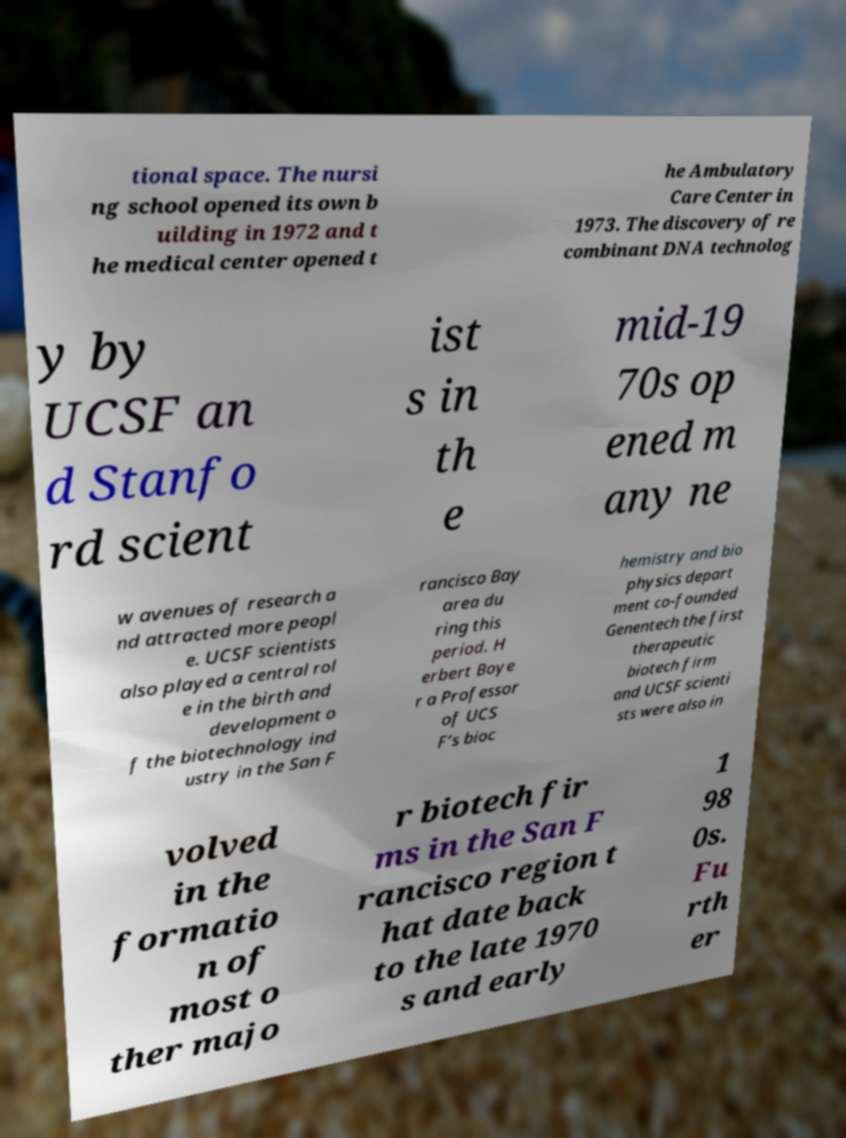Can you accurately transcribe the text from the provided image for me? tional space. The nursi ng school opened its own b uilding in 1972 and t he medical center opened t he Ambulatory Care Center in 1973. The discovery of re combinant DNA technolog y by UCSF an d Stanfo rd scient ist s in th e mid-19 70s op ened m any ne w avenues of research a nd attracted more peopl e. UCSF scientists also played a central rol e in the birth and development o f the biotechnology ind ustry in the San F rancisco Bay area du ring this period. H erbert Boye r a Professor of UCS F’s bioc hemistry and bio physics depart ment co-founded Genentech the first therapeutic biotech firm and UCSF scienti sts were also in volved in the formatio n of most o ther majo r biotech fir ms in the San F rancisco region t hat date back to the late 1970 s and early 1 98 0s. Fu rth er 